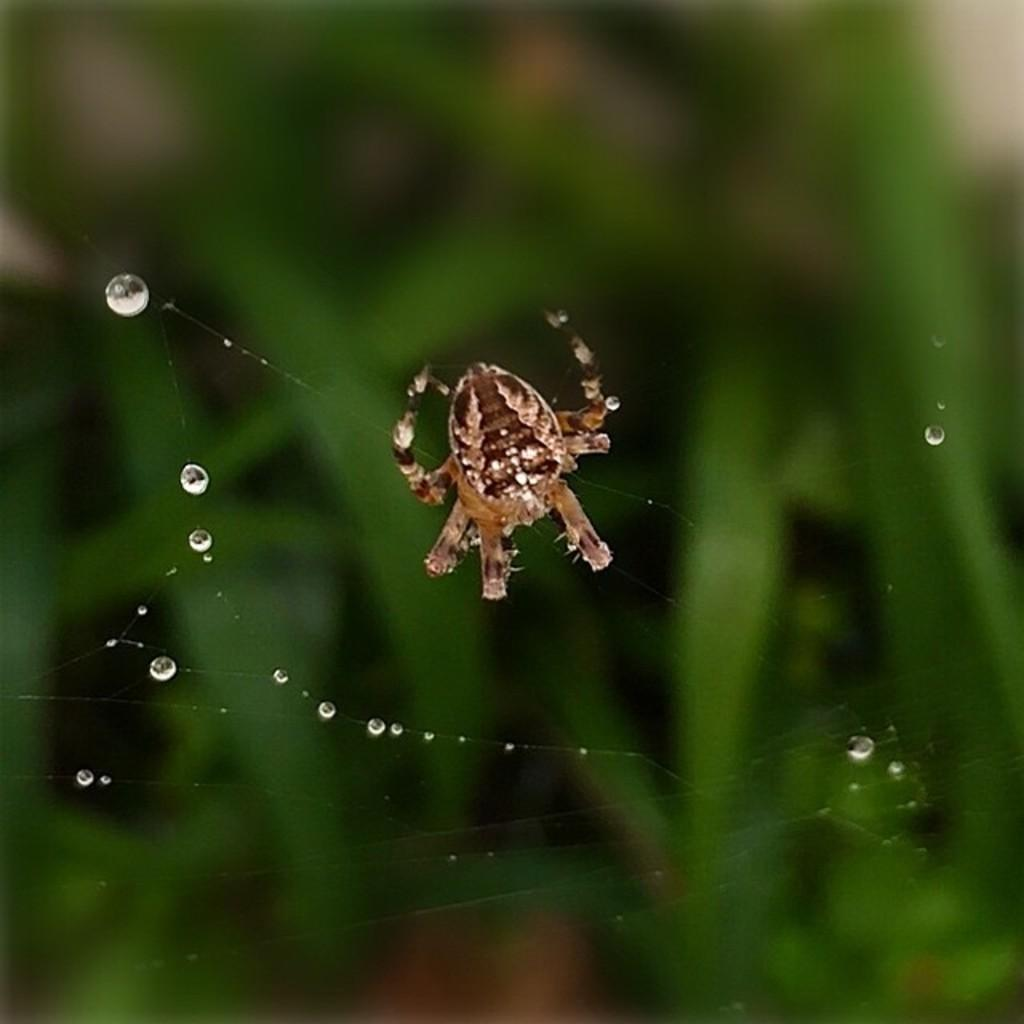What is the main subject of the image? There is a spider in the image. Where is the spider located? The spider is on a web. What can be seen on the web? There are water droplets on the web. What is visible in the background of the image? There are plants in the background of the image, but they are not clearly visible. How does the spider use its tongue to climb the hill in the image? There is no hill or tongue present in the image; it features a spider on a web with water droplets. 